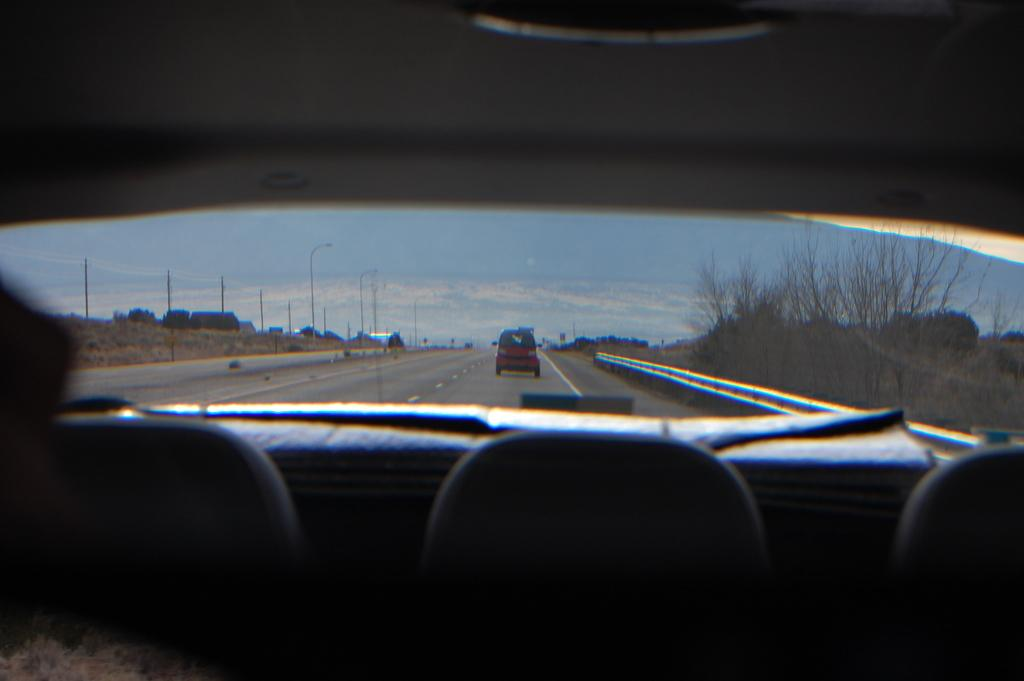What is the perspective of the image? The image is captured from inside a car. What can be seen moving on the road in the image? There is another vehicle moving on the road in the image. What is on the left side of the image? There is a wall on the left side of the image. What is on the right side of the image? There are many dry trees on the right side of the image. What type of parcel is being delivered by the judge in the image? There is no parcel or judge present in the image. How does the mask affect the driver's visibility in the image? There is no mask or driver visible in the image. 